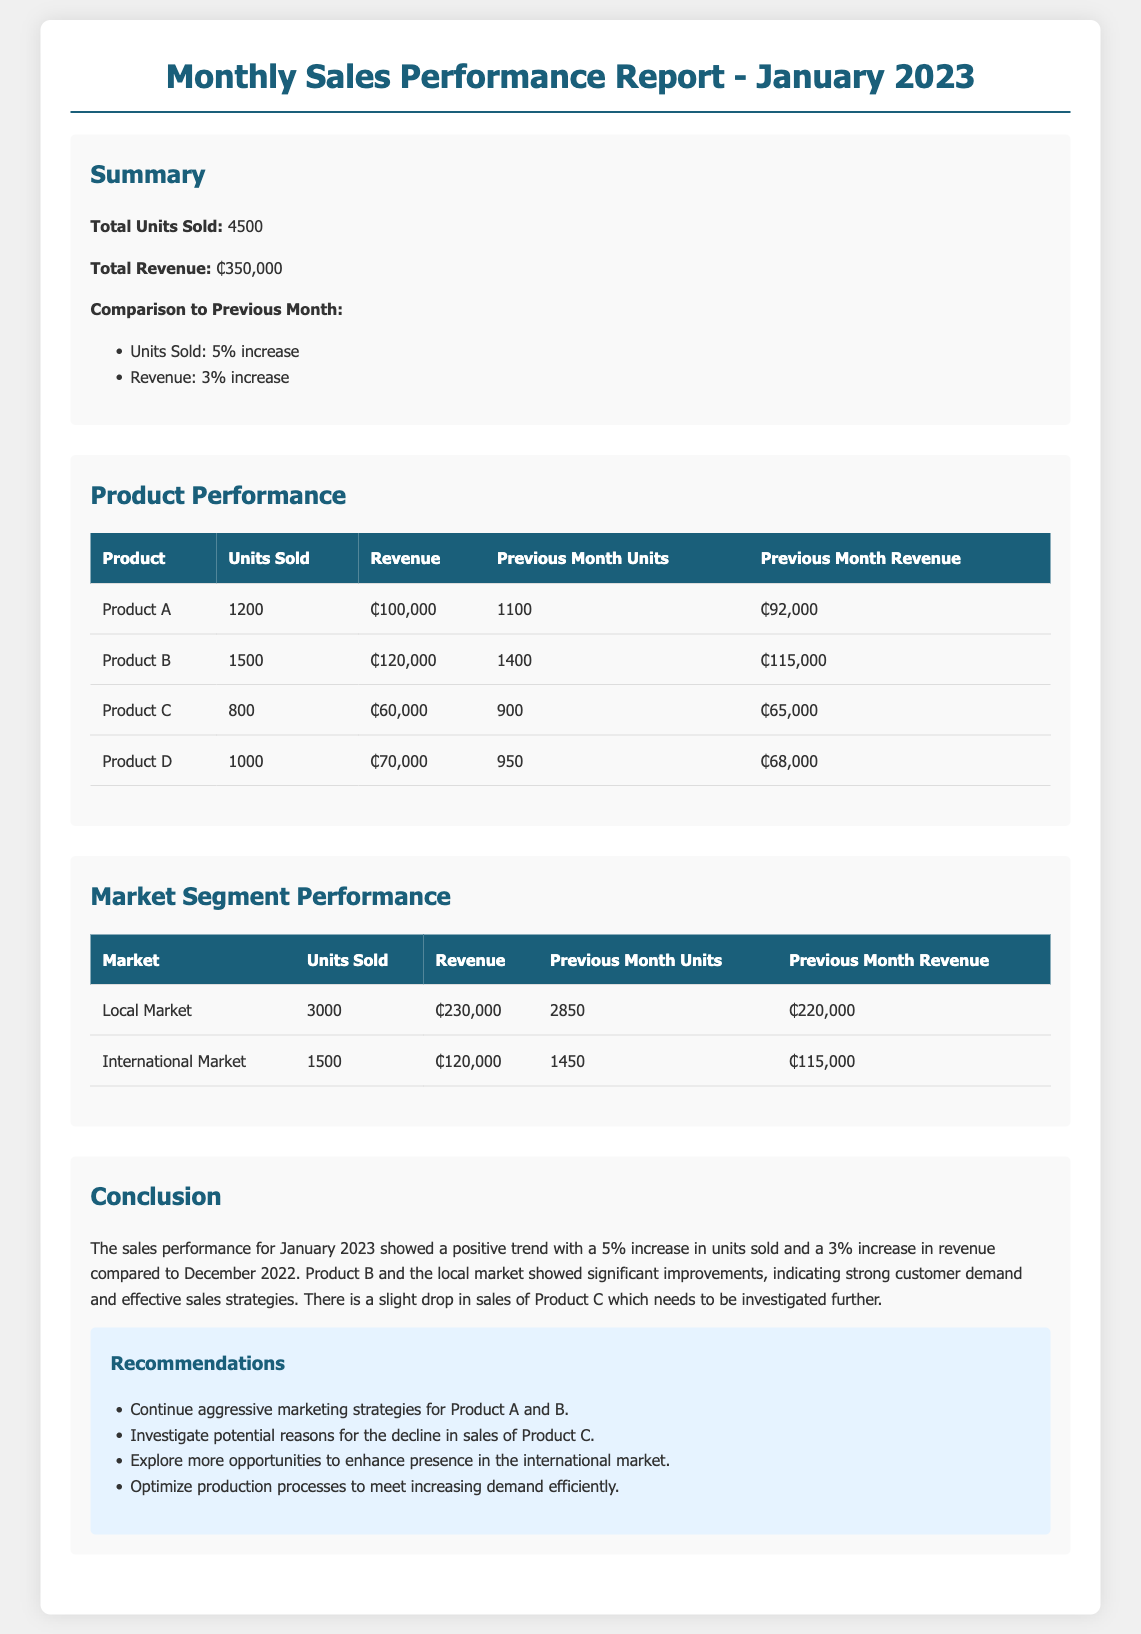What is the total units sold in January 2023? The total units sold is stated in the summary section of the document.
Answer: 4500 What is the revenue generated from Product B? The revenue for Product B can be found in the product performance table.
Answer: ₵120,000 What was the percentage increase in revenue compared to the previous month? The document provides a comparison in the summary section indicating the change in revenue.
Answer: 3% How many units of Product C were sold in December 2022? The previous month units sold for Product C can be found in the product performance table.
Answer: 900 Which market segment sold the most units? This information is evident from the market segment performance table in the document.
Answer: Local Market What does the conclusion state about the sales performance for January 2023? The conclusion summarizes the overall assessment of the sales data, highlighting trends and significant changes.
Answer: Positive trend How many units were sold in the International Market? The total units sold in the International Market can be found in the market segment performance table.
Answer: 1500 What recommendation is given regarding Product C? The recommendations section includes actions to be taken based on the sales data for Product C.
Answer: Investigate potential reasons for the decline in sales of Product C 